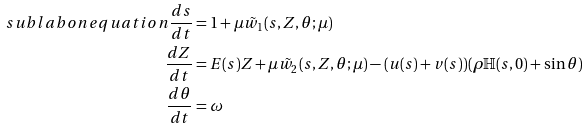Convert formula to latex. <formula><loc_0><loc_0><loc_500><loc_500>\ s u b l a b o n { e q u a t i o n } \frac { d s } { d t } & = 1 + \mu \tilde { w } _ { 1 } ( s , Z , \theta ; \mu ) \\ \frac { d Z } { d t } & = E ( s ) Z + \mu \tilde { w } _ { 2 } ( s , Z , \theta ; \mu ) - ( u ( s ) + v ( s ) ) ( \rho { \mathbb { H } } ( s , 0 ) + \sin \theta ) \\ \frac { d \theta } { d t } & = \omega</formula> 